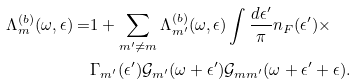<formula> <loc_0><loc_0><loc_500><loc_500>\Lambda _ { m } ^ { ( b ) } ( \omega , \epsilon ) = & 1 + \sum _ { m ^ { \prime } \neq m } \Lambda _ { m ^ { \prime } } ^ { ( b ) } ( \omega , \epsilon ) \int \frac { d \epsilon ^ { \prime } } { \pi } n _ { F } ( \epsilon ^ { \prime } ) \times \\ & \Gamma _ { m ^ { \prime } } ( \epsilon ^ { \prime } ) \mathcal { G } _ { m ^ { \prime } } ( \omega + \epsilon ^ { \prime } ) \mathcal { G } _ { m m ^ { \prime } } ( \omega + \epsilon ^ { \prime } + \epsilon ) .</formula> 